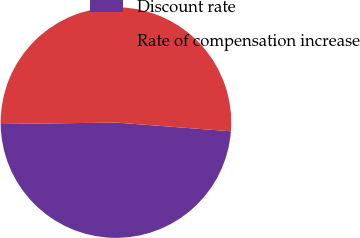Convert chart. <chart><loc_0><loc_0><loc_500><loc_500><pie_chart><fcel>Discount rate<fcel>Rate of compensation increase<nl><fcel>48.59%<fcel>51.41%<nl></chart> 